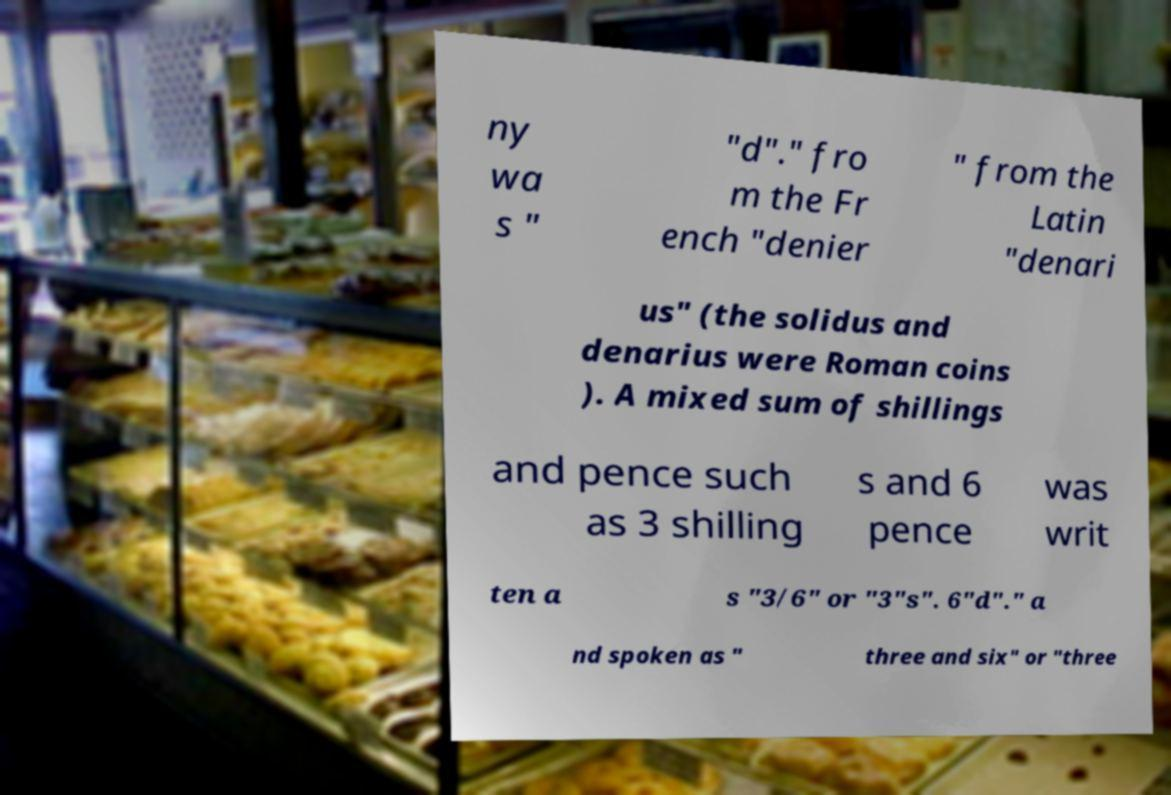Please read and relay the text visible in this image. What does it say? ny wa s " "d"." fro m the Fr ench "denier " from the Latin "denari us" (the solidus and denarius were Roman coins ). A mixed sum of shillings and pence such as 3 shilling s and 6 pence was writ ten a s "3/6" or "3"s". 6"d"." a nd spoken as " three and six" or "three 